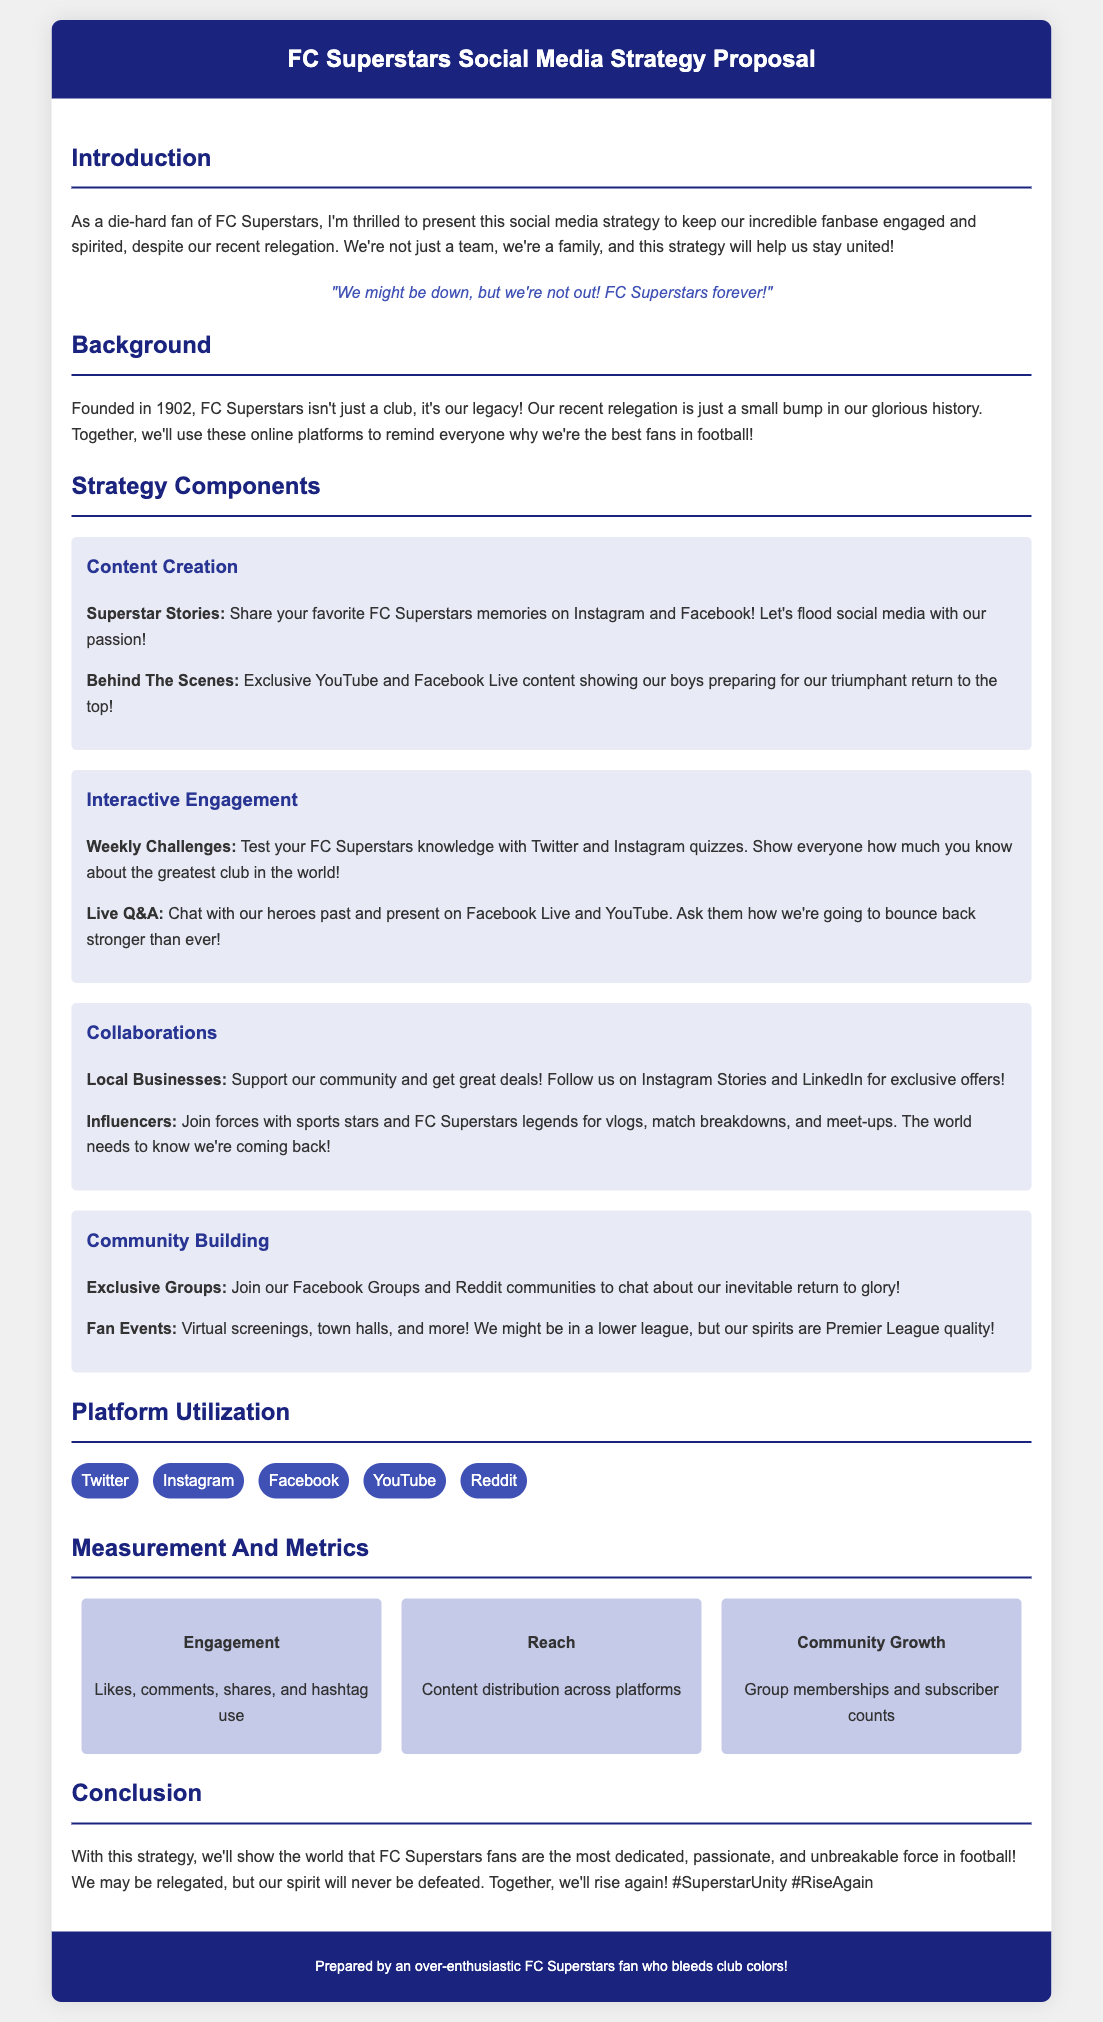what is the title of the proposal? The title of the proposal is prominently displayed at the top of the document.
Answer: FC Superstars Social Media Strategy Proposal what year was FC Superstars founded? The document states the founding year of the club in the background section, emphasizing its history.
Answer: 1902 what is one of the proposed content creation strategies? The document lists strategies in the strategy components section, highlighting various methods to engage fans.
Answer: Superstar Stories which platform is mentioned for live Q&A sessions? The strategy component lists platforms for different engagement activities.
Answer: Facebook Live how many types of metrics are mentioned in the measurement section? The document specifies different metrics used to evaluate engagement strategies.
Answer: 3 what is one of the hashtags suggested for fan unity? The conclusion section of the document encourages the use of hashtags to promote fan engagement.
Answer: #SuperstarUnity what is the main goal of the social media strategy? The introduction and conclusion sections emphasize the overall intention of the strategy.
Answer: Maintain morale what type of businesses does the proposal suggest collaborating with? The document outlines potential partnerships in the collaborations section.
Answer: Local Businesses what is the color theme of the header? The color scheme is mentioned in the style section, applying to various elements of the document.
Answer: Dark Blue 